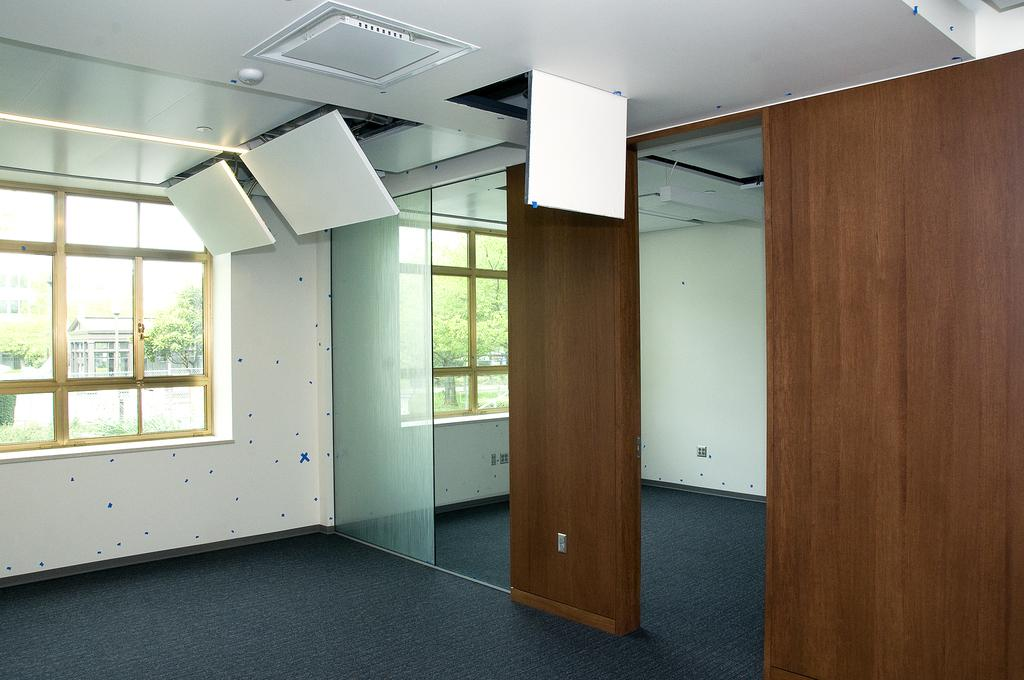What type of structures can be seen in the image? There are walls and windows visible in the image. What material is used for the windows? There is glass in the image, which is used for the windows. What is on the floor in the image? There is a carpet in the image. What can be seen through the windows? Trees and a building are visible through the windows. What else is present in the image besides the walls, windows, and carpet? There are objects in the image. Can you touch the bread in the image? There is no bread present in the image, so it cannot be touched. What type of gate is visible in the image? There is no gate present in the image. 